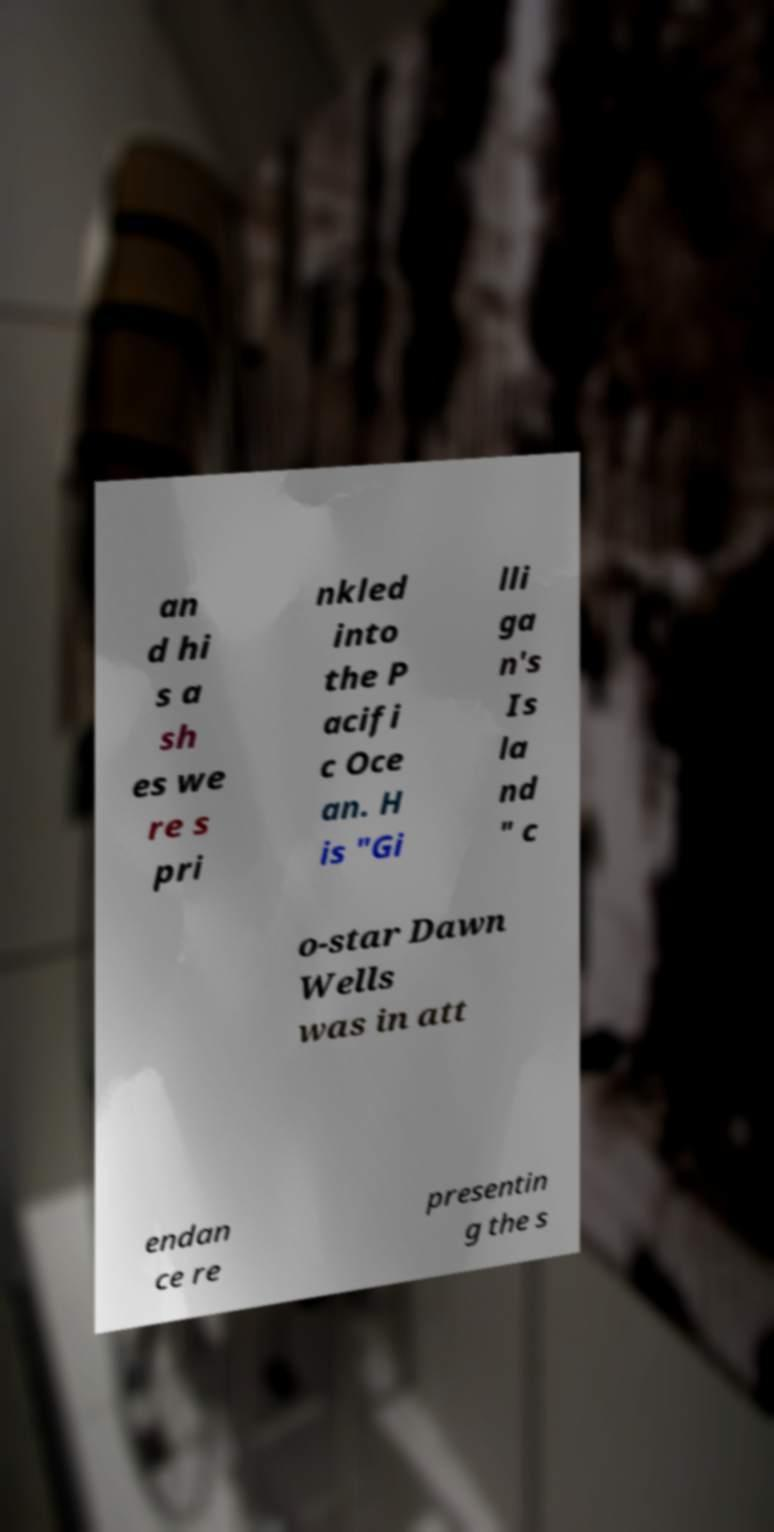Could you extract and type out the text from this image? an d hi s a sh es we re s pri nkled into the P acifi c Oce an. H is "Gi lli ga n's Is la nd " c o-star Dawn Wells was in att endan ce re presentin g the s 